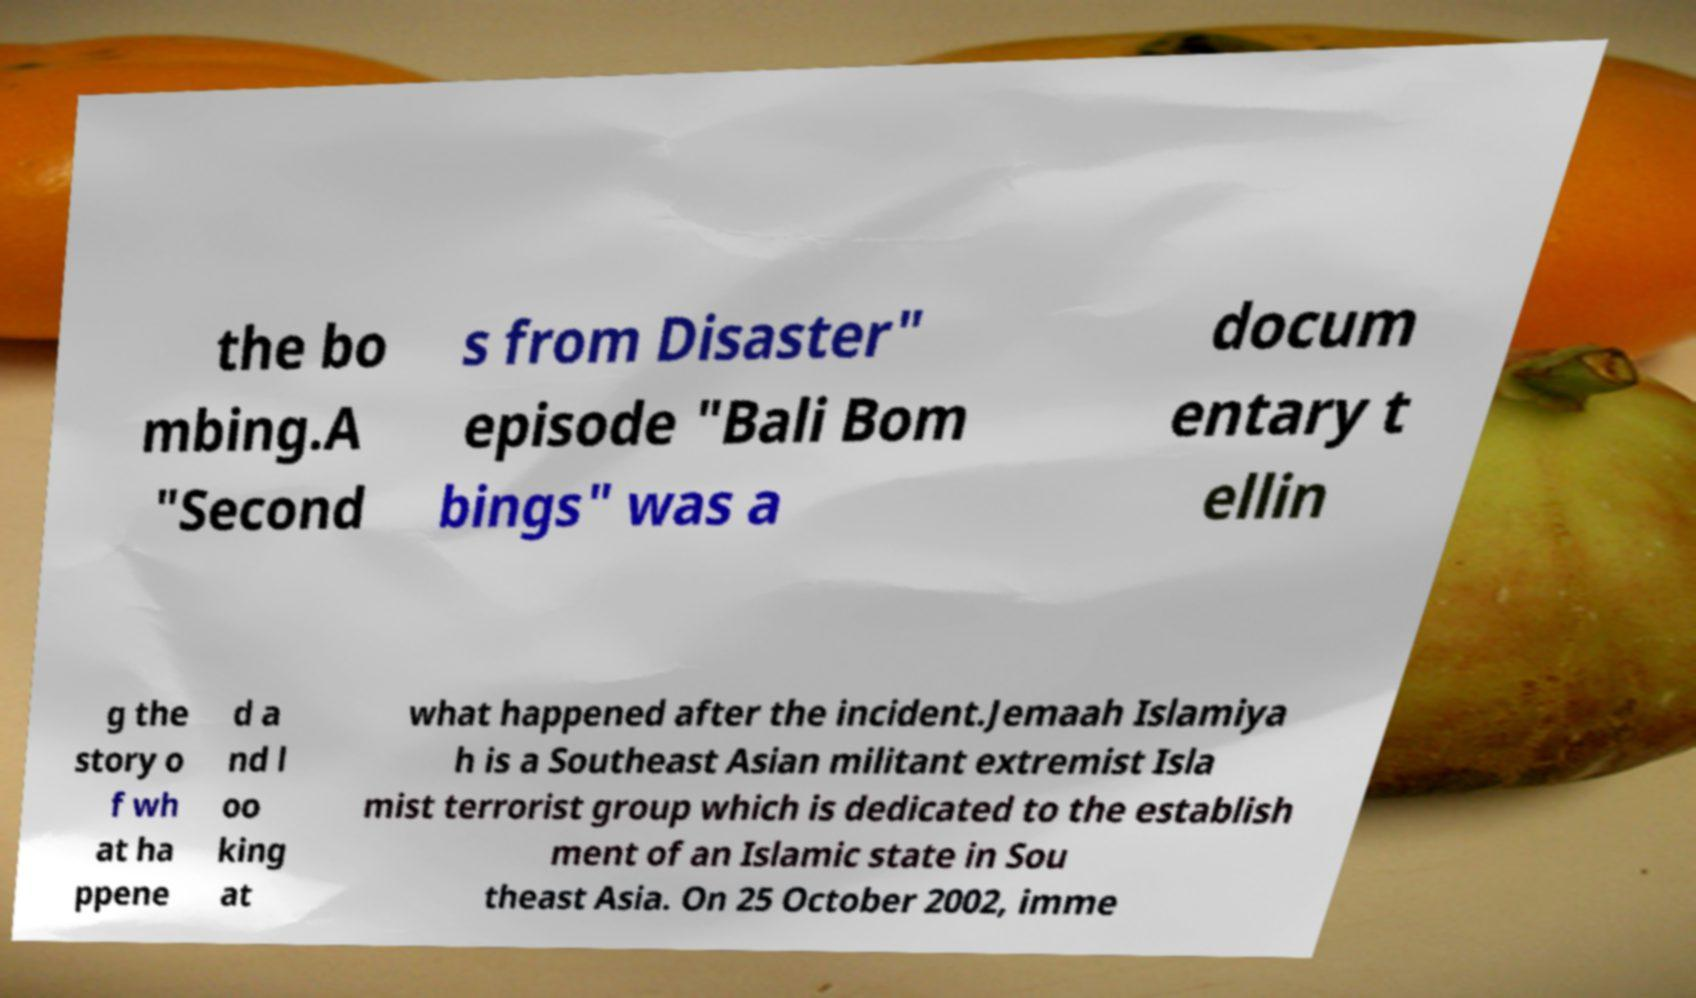There's text embedded in this image that I need extracted. Can you transcribe it verbatim? the bo mbing.A "Second s from Disaster" episode "Bali Bom bings" was a docum entary t ellin g the story o f wh at ha ppene d a nd l oo king at what happened after the incident.Jemaah Islamiya h is a Southeast Asian militant extremist Isla mist terrorist group which is dedicated to the establish ment of an Islamic state in Sou theast Asia. On 25 October 2002, imme 